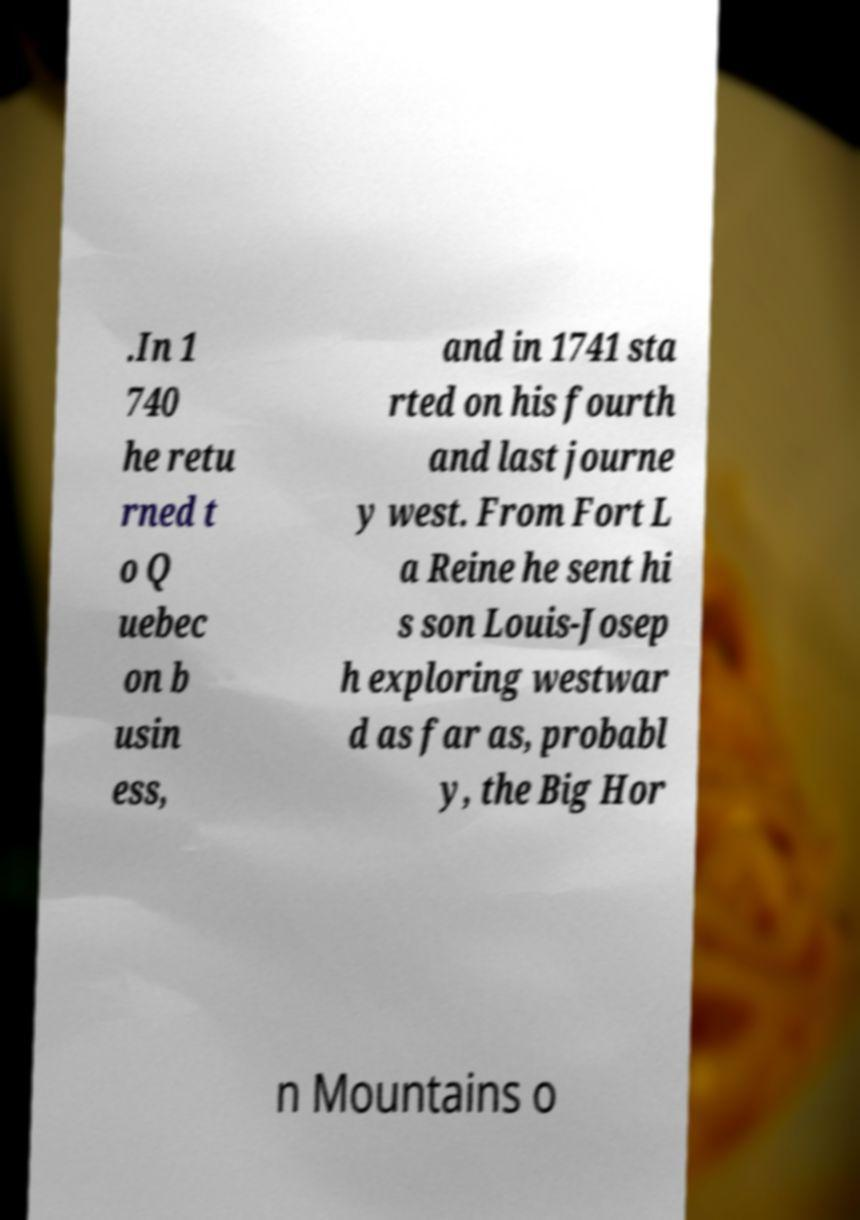Can you accurately transcribe the text from the provided image for me? .In 1 740 he retu rned t o Q uebec on b usin ess, and in 1741 sta rted on his fourth and last journe y west. From Fort L a Reine he sent hi s son Louis-Josep h exploring westwar d as far as, probabl y, the Big Hor n Mountains o 